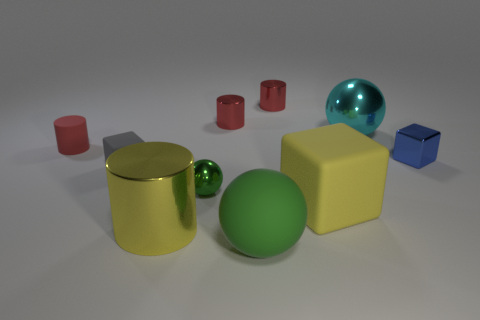There is another metallic thing that is the same shape as the cyan metallic object; what is its color?
Your answer should be compact. Green. Do the shiny thing in front of the tiny green metallic ball and the big matte block have the same color?
Keep it short and to the point. Yes. What size is the other metallic thing that is the same shape as the large cyan thing?
Your answer should be compact. Small. There is a small rubber object in front of the small red rubber object; is its shape the same as the big matte thing that is behind the rubber ball?
Your response must be concise. Yes. Is there a yellow matte cube of the same size as the yellow metal thing?
Your response must be concise. Yes. What material is the big ball that is behind the yellow metal object?
Provide a short and direct response. Metal. Are the big ball that is to the left of the cyan thing and the tiny gray thing made of the same material?
Keep it short and to the point. Yes. Is there a sphere?
Offer a very short reply. Yes. The other big thing that is the same material as the large green thing is what color?
Offer a terse response. Yellow. There is a big ball behind the tiny block that is on the left side of the block behind the small rubber cube; what color is it?
Make the answer very short. Cyan. 